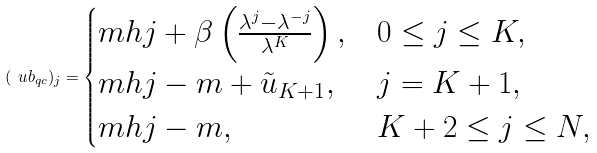<formula> <loc_0><loc_0><loc_500><loc_500>( \ u b _ { q c } ) _ { j } = \begin{cases} m h j + \beta \left ( \frac { \lambda ^ { j } - \lambda ^ { - j } } { \lambda ^ { K } } \right ) , & 0 \leq j \leq K , \\ m h j - m + \tilde { u } _ { K + 1 } , & j = K + 1 , \\ m h j - m , & K + 2 \leq j \leq N , \end{cases}</formula> 